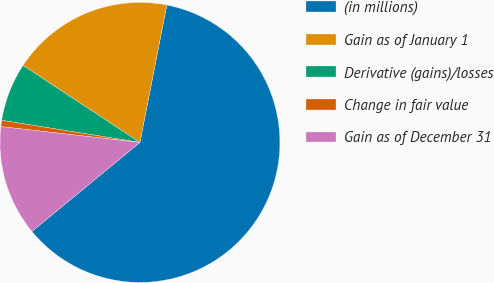Convert chart to OTSL. <chart><loc_0><loc_0><loc_500><loc_500><pie_chart><fcel>(in millions)<fcel>Gain as of January 1<fcel>Derivative (gains)/losses<fcel>Change in fair value<fcel>Gain as of December 31<nl><fcel>60.96%<fcel>18.8%<fcel>6.75%<fcel>0.72%<fcel>12.77%<nl></chart> 